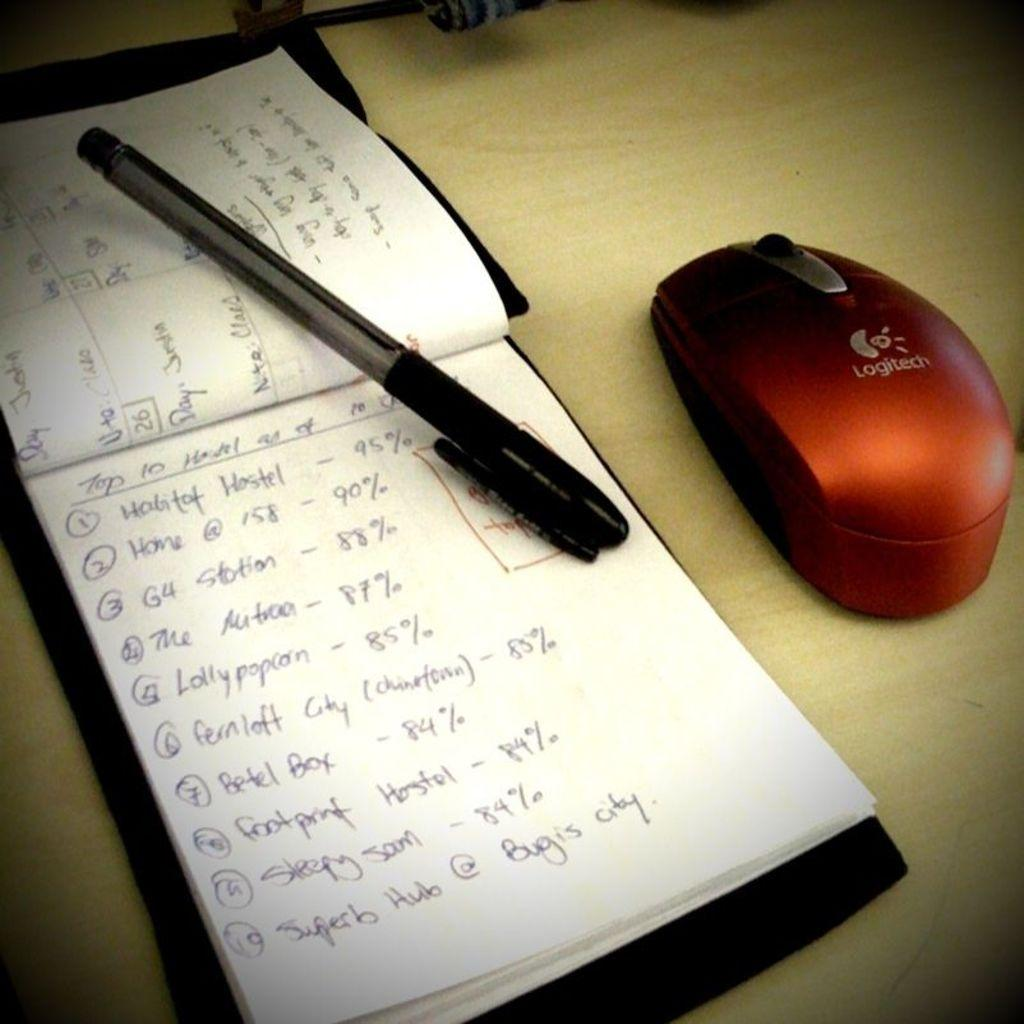What object related to reading can be seen in the image? There is a book in the image. What writing instrument is present in the image? There is a pen in the image. What type of animal is in the image? There is a mouse in the image. What color is the mouse? The mouse is red. What is the color of the table in the image? The table is brown. What type of vegetable is being prepared for the meal in the image? There is no meal or vegetable present in the image. What type of pipe can be seen in the image? There is no pipe present in the image. 